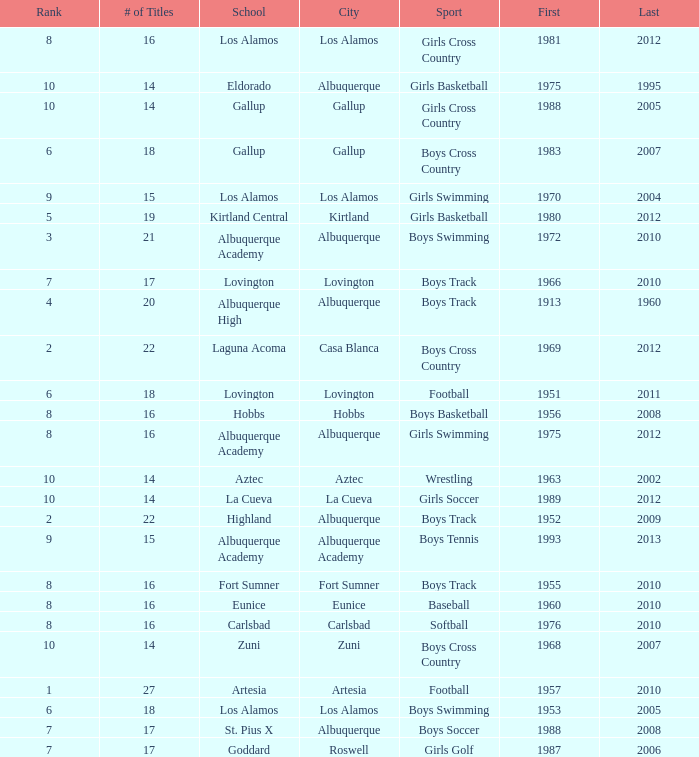Can you give me this table as a dict? {'header': ['Rank', '# of Titles', 'School', 'City', 'Sport', 'First', 'Last'], 'rows': [['8', '16', 'Los Alamos', 'Los Alamos', 'Girls Cross Country', '1981', '2012'], ['10', '14', 'Eldorado', 'Albuquerque', 'Girls Basketball', '1975', '1995'], ['10', '14', 'Gallup', 'Gallup', 'Girls Cross Country', '1988', '2005'], ['6', '18', 'Gallup', 'Gallup', 'Boys Cross Country', '1983', '2007'], ['9', '15', 'Los Alamos', 'Los Alamos', 'Girls Swimming', '1970', '2004'], ['5', '19', 'Kirtland Central', 'Kirtland', 'Girls Basketball', '1980', '2012'], ['3', '21', 'Albuquerque Academy', 'Albuquerque', 'Boys Swimming', '1972', '2010'], ['7', '17', 'Lovington', 'Lovington', 'Boys Track', '1966', '2010'], ['4', '20', 'Albuquerque High', 'Albuquerque', 'Boys Track', '1913', '1960'], ['2', '22', 'Laguna Acoma', 'Casa Blanca', 'Boys Cross Country', '1969', '2012'], ['6', '18', 'Lovington', 'Lovington', 'Football', '1951', '2011'], ['8', '16', 'Hobbs', 'Hobbs', 'Boys Basketball', '1956', '2008'], ['8', '16', 'Albuquerque Academy', 'Albuquerque', 'Girls Swimming', '1975', '2012'], ['10', '14', 'Aztec', 'Aztec', 'Wrestling', '1963', '2002'], ['10', '14', 'La Cueva', 'La Cueva', 'Girls Soccer', '1989', '2012'], ['2', '22', 'Highland', 'Albuquerque', 'Boys Track', '1952', '2009'], ['9', '15', 'Albuquerque Academy', 'Albuquerque Academy', 'Boys Tennis', '1993', '2013'], ['8', '16', 'Fort Sumner', 'Fort Sumner', 'Boys Track', '1955', '2010'], ['8', '16', 'Eunice', 'Eunice', 'Baseball', '1960', '2010'], ['8', '16', 'Carlsbad', 'Carlsbad', 'Softball', '1976', '2010'], ['10', '14', 'Zuni', 'Zuni', 'Boys Cross Country', '1968', '2007'], ['1', '27', 'Artesia', 'Artesia', 'Football', '1957', '2010'], ['6', '18', 'Los Alamos', 'Los Alamos', 'Boys Swimming', '1953', '2005'], ['7', '17', 'St. Pius X', 'Albuquerque', 'Boys Soccer', '1988', '2008'], ['7', '17', 'Goddard', 'Roswell', 'Girls Golf', '1987', '2006']]} What city is the School, Highland, in that ranks less than 8 and had its first title before 1980 and its last title later than 1960? Albuquerque. 